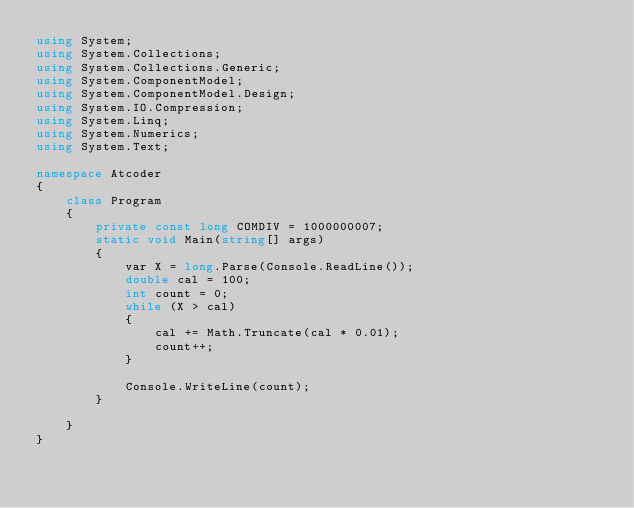Convert code to text. <code><loc_0><loc_0><loc_500><loc_500><_C#_>using System;
using System.Collections;
using System.Collections.Generic;
using System.ComponentModel;
using System.ComponentModel.Design;
using System.IO.Compression;
using System.Linq;
using System.Numerics;
using System.Text;

namespace Atcoder
{
    class Program
    {
        private const long COMDIV = 1000000007;
        static void Main(string[] args)
        {
            var X = long.Parse(Console.ReadLine());
            double cal = 100;
            int count = 0;
            while (X > cal)
            {
                cal += Math.Truncate(cal * 0.01);
                count++;
            }

            Console.WriteLine(count);
        }
        
    }
}</code> 